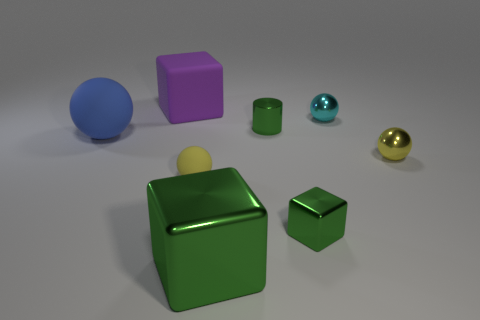Is there a cyan shiny sphere that is left of the tiny green shiny object that is in front of the green metal cylinder?
Give a very brief answer. No. There is a large purple rubber object; what shape is it?
Give a very brief answer. Cube. There is a cylinder that is the same color as the big metal thing; what size is it?
Keep it short and to the point. Small. There is a matte object behind the tiny ball behind the blue matte ball; what is its size?
Offer a terse response. Large. There is a metal sphere that is right of the tiny cyan sphere; what is its size?
Give a very brief answer. Small. Is the number of balls in front of the big blue rubber object less than the number of small shiny balls behind the tiny yellow shiny thing?
Offer a terse response. No. What is the color of the tiny metallic cylinder?
Your answer should be compact. Green. Is there a tiny thing of the same color as the big shiny block?
Your answer should be compact. Yes. There is a yellow thing behind the rubber ball that is in front of the small yellow sphere right of the metallic cylinder; what shape is it?
Provide a short and direct response. Sphere. What material is the large block left of the large metal object?
Ensure brevity in your answer.  Rubber. 